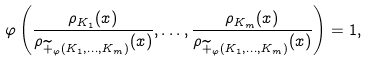Convert formula to latex. <formula><loc_0><loc_0><loc_500><loc_500>\varphi \left ( \frac { \rho _ { K _ { 1 } } ( x ) } { \rho _ { \widetilde { + } _ { \varphi } ( K _ { 1 } , \dots , K _ { m } ) } ( x ) } , \dots , \frac { \rho _ { K _ { m } } ( x ) } { \rho _ { \widetilde { + } _ { \varphi } ( K _ { 1 } , \dots , K _ { m } ) } ( x ) } \right ) = 1 ,</formula> 